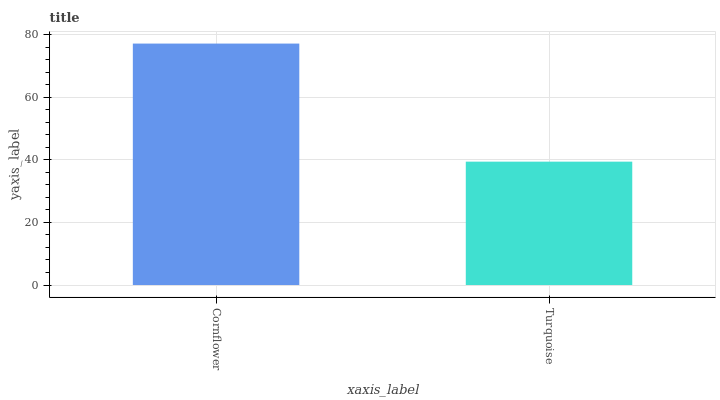Is Turquoise the minimum?
Answer yes or no. Yes. Is Cornflower the maximum?
Answer yes or no. Yes. Is Turquoise the maximum?
Answer yes or no. No. Is Cornflower greater than Turquoise?
Answer yes or no. Yes. Is Turquoise less than Cornflower?
Answer yes or no. Yes. Is Turquoise greater than Cornflower?
Answer yes or no. No. Is Cornflower less than Turquoise?
Answer yes or no. No. Is Cornflower the high median?
Answer yes or no. Yes. Is Turquoise the low median?
Answer yes or no. Yes. Is Turquoise the high median?
Answer yes or no. No. Is Cornflower the low median?
Answer yes or no. No. 